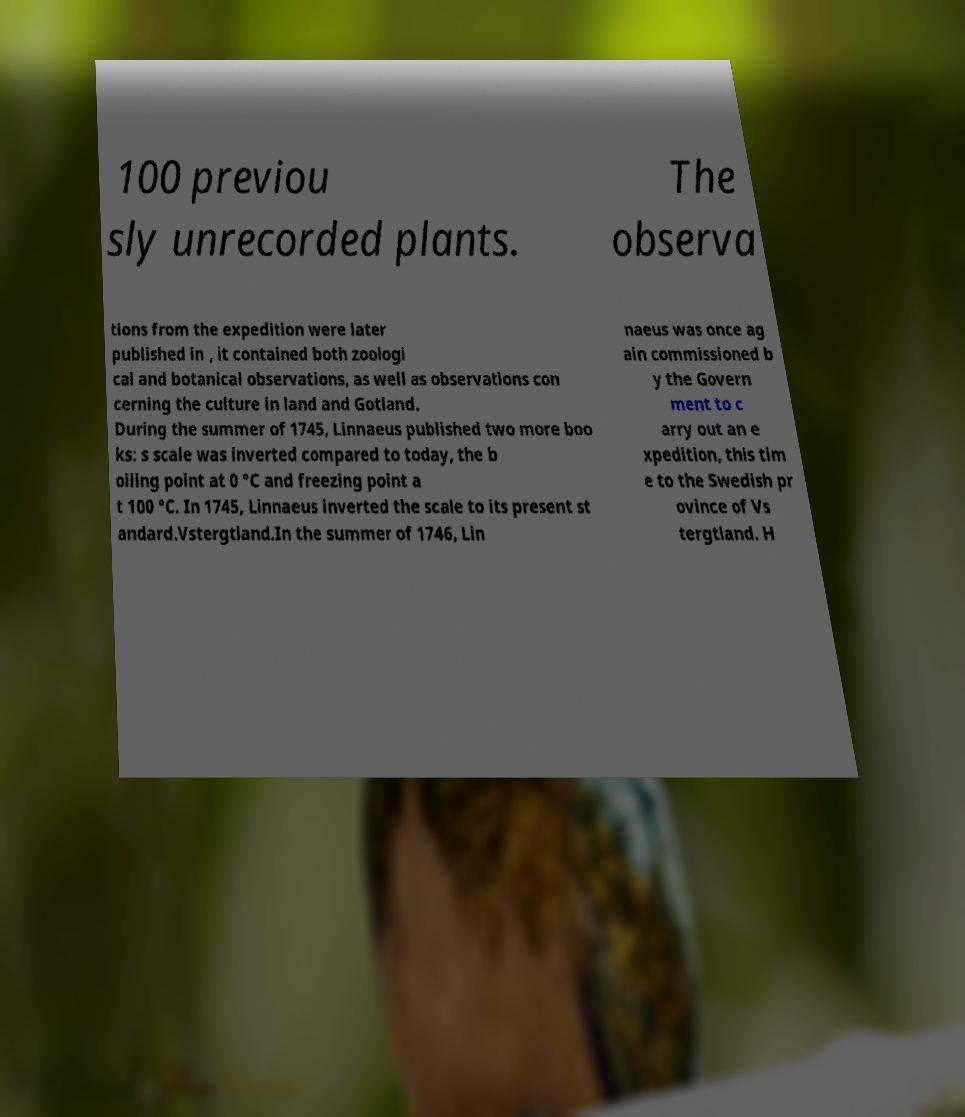I need the written content from this picture converted into text. Can you do that? 100 previou sly unrecorded plants. The observa tions from the expedition were later published in , it contained both zoologi cal and botanical observations, as well as observations con cerning the culture in land and Gotland. During the summer of 1745, Linnaeus published two more boo ks: s scale was inverted compared to today, the b oiling point at 0 °C and freezing point a t 100 °C. In 1745, Linnaeus inverted the scale to its present st andard.Vstergtland.In the summer of 1746, Lin naeus was once ag ain commissioned b y the Govern ment to c arry out an e xpedition, this tim e to the Swedish pr ovince of Vs tergtland. H 